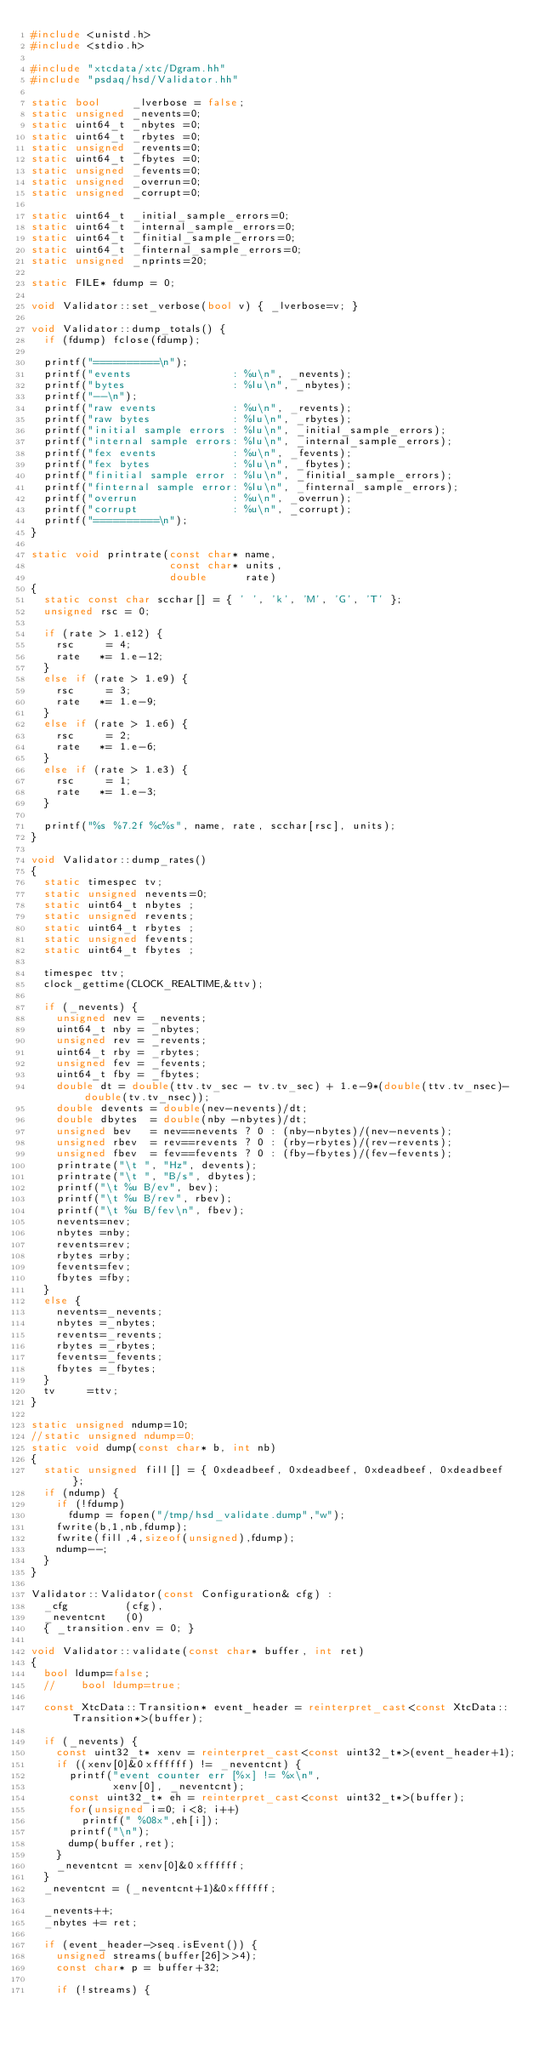Convert code to text. <code><loc_0><loc_0><loc_500><loc_500><_C++_>#include <unistd.h>
#include <stdio.h>

#include "xtcdata/xtc/Dgram.hh"
#include "psdaq/hsd/Validator.hh"

static bool     _lverbose = false;
static unsigned _nevents=0;
static uint64_t _nbytes =0;
static uint64_t _rbytes =0;
static unsigned _revents=0;
static uint64_t _fbytes =0;
static unsigned _fevents=0;
static unsigned _overrun=0;
static unsigned _corrupt=0;

static uint64_t _initial_sample_errors=0;
static uint64_t _internal_sample_errors=0;
static uint64_t _finitial_sample_errors=0;
static uint64_t _finternal_sample_errors=0;
static unsigned _nprints=20;

static FILE* fdump = 0;

void Validator::set_verbose(bool v) { _lverbose=v; }

void Validator::dump_totals() {
  if (fdump) fclose(fdump);

  printf("==========\n");
  printf("events                : %u\n", _nevents);
  printf("bytes                 : %lu\n", _nbytes);
  printf("--\n");
  printf("raw events            : %u\n", _revents);
  printf("raw bytes             : %lu\n", _rbytes);
  printf("initial sample errors : %lu\n", _initial_sample_errors);
  printf("internal sample errors: %lu\n", _internal_sample_errors);
  printf("fex events            : %u\n", _fevents);
  printf("fex bytes             : %lu\n", _fbytes);
  printf("finitial sample error : %lu\n", _finitial_sample_errors);
  printf("finternal sample error: %lu\n", _finternal_sample_errors);
  printf("overrun               : %u\n", _overrun);
  printf("corrupt               : %u\n", _corrupt);
  printf("==========\n");
}

static void printrate(const char* name,
                      const char* units,
                      double      rate)
{
  static const char scchar[] = { ' ', 'k', 'M', 'G', 'T' };
  unsigned rsc = 0;

  if (rate > 1.e12) {
    rsc     = 4;
    rate   *= 1.e-12;
  }
  else if (rate > 1.e9) {
    rsc     = 3;
    rate   *= 1.e-9;
  }
  else if (rate > 1.e6) {
    rsc     = 2;
    rate   *= 1.e-6;
  }
  else if (rate > 1.e3) {
    rsc     = 1;
    rate   *= 1.e-3;
  }

  printf("%s %7.2f %c%s", name, rate, scchar[rsc], units);
}

void Validator::dump_rates()
{
  static timespec tv;
  static unsigned nevents=0;
  static uint64_t nbytes ;
  static unsigned revents;
  static uint64_t rbytes ;
  static unsigned fevents;
  static uint64_t fbytes ;

  timespec ttv;
  clock_gettime(CLOCK_REALTIME,&ttv);

  if (_nevents) {
    unsigned nev = _nevents;
    uint64_t nby = _nbytes;
    unsigned rev = _revents;
    uint64_t rby = _rbytes;
    unsigned fev = _fevents;
    uint64_t fby = _fbytes;
    double dt = double(ttv.tv_sec - tv.tv_sec) + 1.e-9*(double(ttv.tv_nsec)-double(tv.tv_nsec));
    double devents = double(nev-nevents)/dt;
    double dbytes  = double(nby -nbytes)/dt;
    unsigned bev   = nev==nevents ? 0 : (nby-nbytes)/(nev-nevents);
    unsigned rbev  = rev==revents ? 0 : (rby-rbytes)/(rev-revents);
    unsigned fbev  = fev==fevents ? 0 : (fby-fbytes)/(fev-fevents);
    printrate("\t ", "Hz", devents);
    printrate("\t ", "B/s", dbytes);
    printf("\t %u B/ev", bev);
    printf("\t %u B/rev", rbev);
    printf("\t %u B/fev\n", fbev);
    nevents=nev;
    nbytes =nby;
    revents=rev;
    rbytes =rby;
    fevents=fev;
    fbytes =fby;
  }
  else {
    nevents=_nevents;
    nbytes =_nbytes;
    revents=_revents;
    rbytes =_rbytes;
    fevents=_fevents;
    fbytes =_fbytes;
  }
  tv     =ttv;
}

static unsigned ndump=10;
//static unsigned ndump=0;
static void dump(const char* b, int nb)
{
  static unsigned fill[] = { 0xdeadbeef, 0xdeadbeef, 0xdeadbeef, 0xdeadbeef };
  if (ndump) {
    if (!fdump) 
      fdump = fopen("/tmp/hsd_validate.dump","w");
    fwrite(b,1,nb,fdump);
    fwrite(fill,4,sizeof(unsigned),fdump);
    ndump--;
  }
}

Validator::Validator(const Configuration& cfg) : 
  _cfg         (cfg),
  _neventcnt   (0)
  { _transition.env = 0; }

void Validator::validate(const char* buffer, int ret)
{
  bool ldump=false;
  //    bool ldump=true;

  const XtcData::Transition* event_header = reinterpret_cast<const XtcData::Transition*>(buffer);

  if (_nevents) {
    const uint32_t* xenv = reinterpret_cast<const uint32_t*>(event_header+1);
    if ((xenv[0]&0xffffff) != _neventcnt) {
      printf("event counter err [%x] != %x\n",
             xenv[0], _neventcnt);
      const uint32_t* eh = reinterpret_cast<const uint32_t*>(buffer);
      for(unsigned i=0; i<8; i++)
        printf(" %08x",eh[i]);
      printf("\n");
      dump(buffer,ret);
    }
    _neventcnt = xenv[0]&0xffffff;
  }
  _neventcnt = (_neventcnt+1)&0xffffff;

  _nevents++;
  _nbytes += ret;

  if (event_header->seq.isEvent()) {
    unsigned streams(buffer[26]>>4);
    const char* p = buffer+32;

    if (!streams) {</code> 